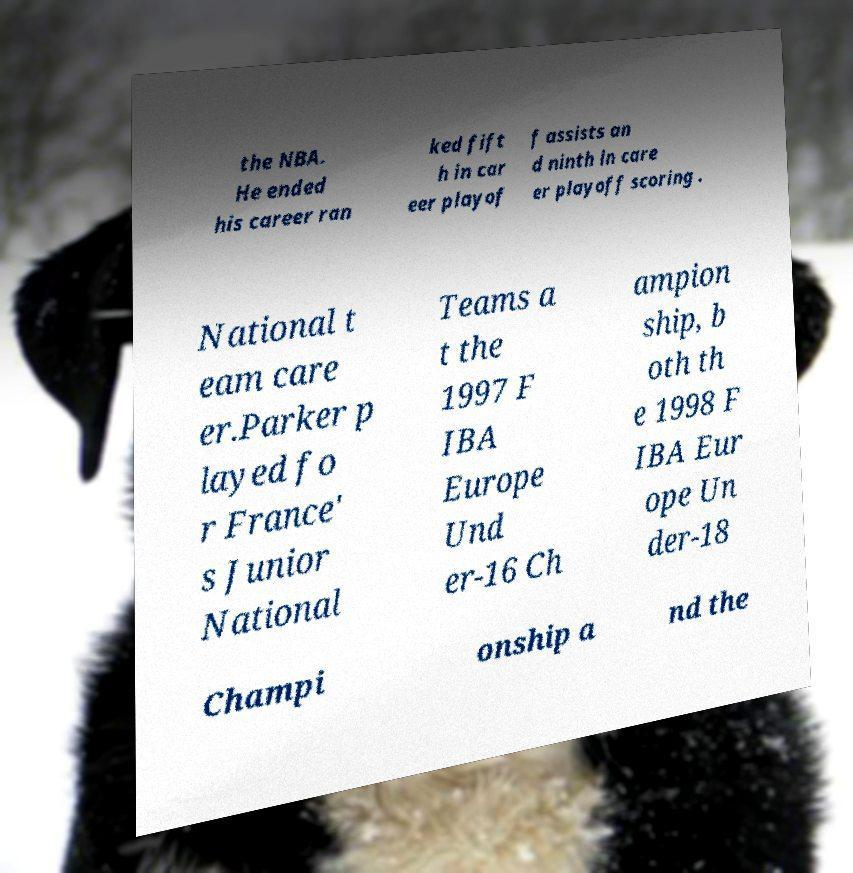Could you extract and type out the text from this image? the NBA. He ended his career ran ked fift h in car eer playof f assists an d ninth in care er playoff scoring . National t eam care er.Parker p layed fo r France' s Junior National Teams a t the 1997 F IBA Europe Und er-16 Ch ampion ship, b oth th e 1998 F IBA Eur ope Un der-18 Champi onship a nd the 